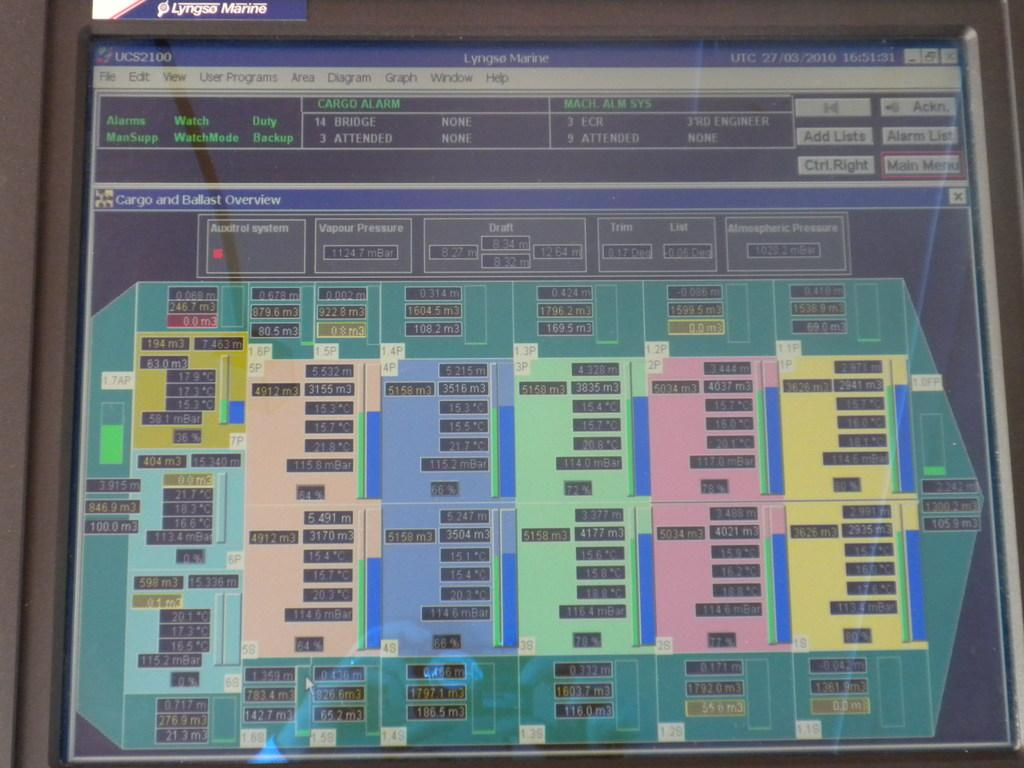Provide a one-sentence caption for the provided image. A display in Lyngso Marine, an apparent map of the inside of a ship. 